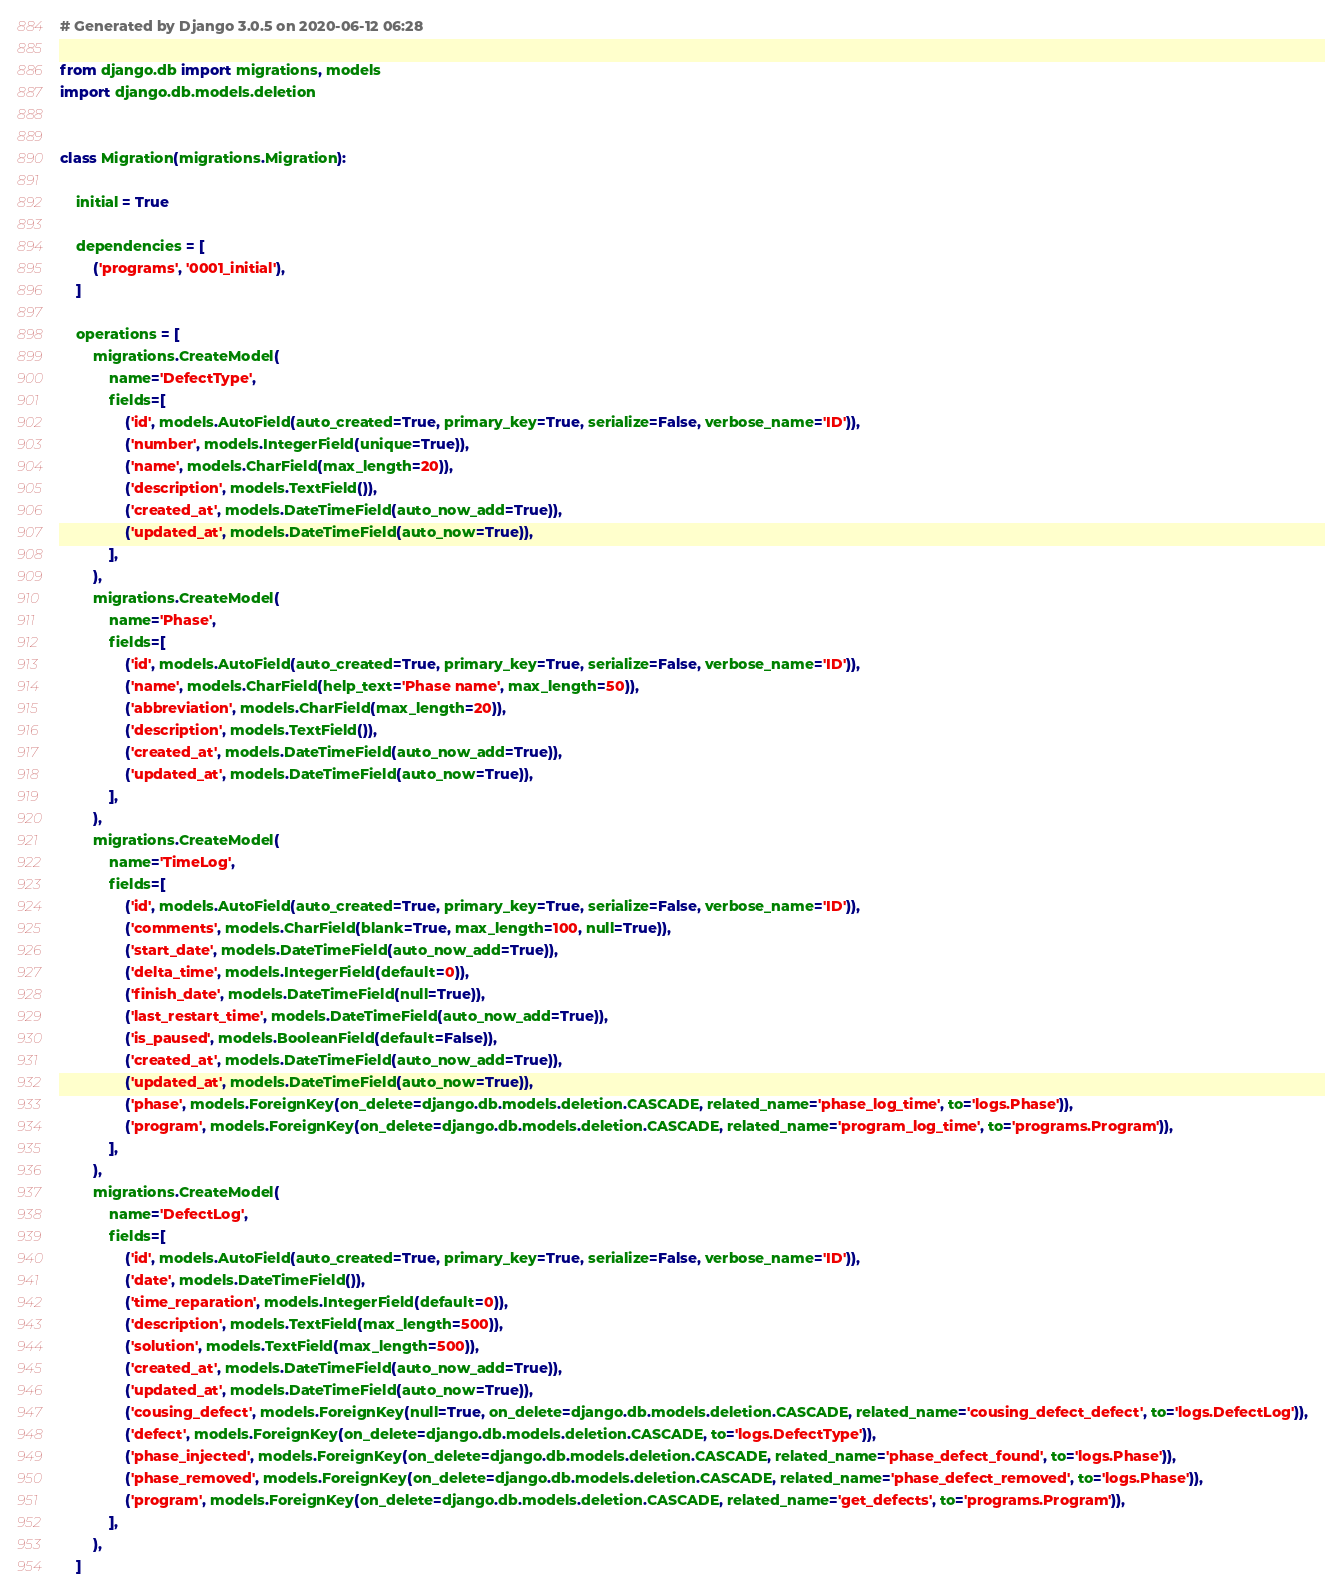<code> <loc_0><loc_0><loc_500><loc_500><_Python_># Generated by Django 3.0.5 on 2020-06-12 06:28

from django.db import migrations, models
import django.db.models.deletion


class Migration(migrations.Migration):

    initial = True

    dependencies = [
        ('programs', '0001_initial'),
    ]

    operations = [
        migrations.CreateModel(
            name='DefectType',
            fields=[
                ('id', models.AutoField(auto_created=True, primary_key=True, serialize=False, verbose_name='ID')),
                ('number', models.IntegerField(unique=True)),
                ('name', models.CharField(max_length=20)),
                ('description', models.TextField()),
                ('created_at', models.DateTimeField(auto_now_add=True)),
                ('updated_at', models.DateTimeField(auto_now=True)),
            ],
        ),
        migrations.CreateModel(
            name='Phase',
            fields=[
                ('id', models.AutoField(auto_created=True, primary_key=True, serialize=False, verbose_name='ID')),
                ('name', models.CharField(help_text='Phase name', max_length=50)),
                ('abbreviation', models.CharField(max_length=20)),
                ('description', models.TextField()),
                ('created_at', models.DateTimeField(auto_now_add=True)),
                ('updated_at', models.DateTimeField(auto_now=True)),
            ],
        ),
        migrations.CreateModel(
            name='TimeLog',
            fields=[
                ('id', models.AutoField(auto_created=True, primary_key=True, serialize=False, verbose_name='ID')),
                ('comments', models.CharField(blank=True, max_length=100, null=True)),
                ('start_date', models.DateTimeField(auto_now_add=True)),
                ('delta_time', models.IntegerField(default=0)),
                ('finish_date', models.DateTimeField(null=True)),
                ('last_restart_time', models.DateTimeField(auto_now_add=True)),
                ('is_paused', models.BooleanField(default=False)),
                ('created_at', models.DateTimeField(auto_now_add=True)),
                ('updated_at', models.DateTimeField(auto_now=True)),
                ('phase', models.ForeignKey(on_delete=django.db.models.deletion.CASCADE, related_name='phase_log_time', to='logs.Phase')),
                ('program', models.ForeignKey(on_delete=django.db.models.deletion.CASCADE, related_name='program_log_time', to='programs.Program')),
            ],
        ),
        migrations.CreateModel(
            name='DefectLog',
            fields=[
                ('id', models.AutoField(auto_created=True, primary_key=True, serialize=False, verbose_name='ID')),
                ('date', models.DateTimeField()),
                ('time_reparation', models.IntegerField(default=0)),
                ('description', models.TextField(max_length=500)),
                ('solution', models.TextField(max_length=500)),
                ('created_at', models.DateTimeField(auto_now_add=True)),
                ('updated_at', models.DateTimeField(auto_now=True)),
                ('cousing_defect', models.ForeignKey(null=True, on_delete=django.db.models.deletion.CASCADE, related_name='cousing_defect_defect', to='logs.DefectLog')),
                ('defect', models.ForeignKey(on_delete=django.db.models.deletion.CASCADE, to='logs.DefectType')),
                ('phase_injected', models.ForeignKey(on_delete=django.db.models.deletion.CASCADE, related_name='phase_defect_found', to='logs.Phase')),
                ('phase_removed', models.ForeignKey(on_delete=django.db.models.deletion.CASCADE, related_name='phase_defect_removed', to='logs.Phase')),
                ('program', models.ForeignKey(on_delete=django.db.models.deletion.CASCADE, related_name='get_defects', to='programs.Program')),
            ],
        ),
    ]
</code> 